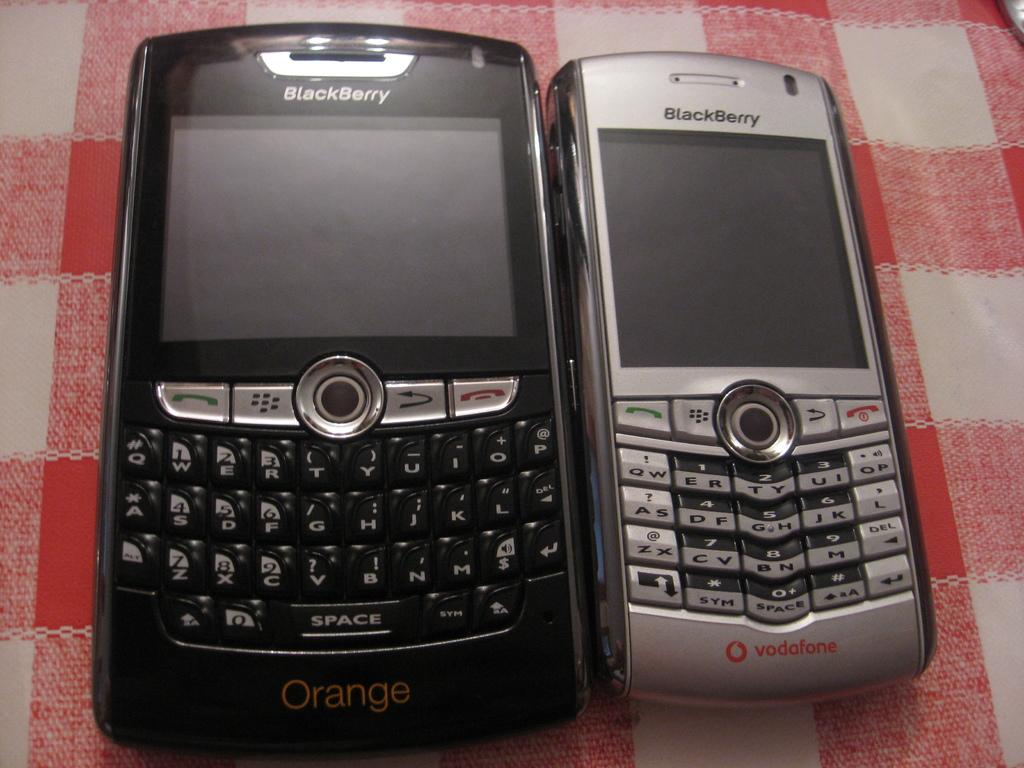How many mobiles can be seen in the image? There are two mobiles in the image. What are the colors of the mobiles? One mobile is black in color, and the other is silver in color. What is the mobiles placed on? The mobiles are placed on a cloth. What is the expression of disgust on the mother's face in the image? There is no mother or expression of disgust present in the image. 